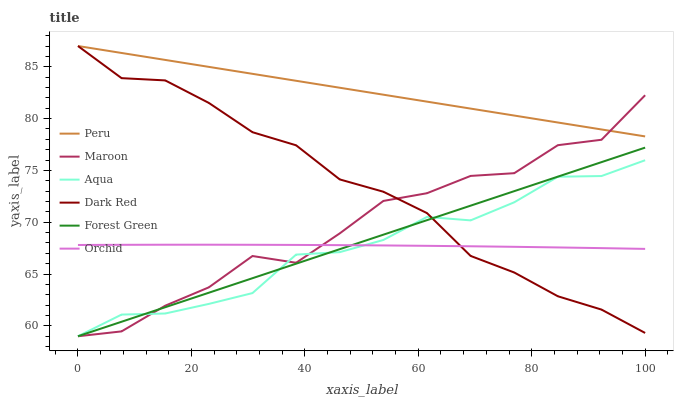Does Aqua have the minimum area under the curve?
Answer yes or no. Yes. Does Peru have the maximum area under the curve?
Answer yes or no. Yes. Does Maroon have the minimum area under the curve?
Answer yes or no. No. Does Maroon have the maximum area under the curve?
Answer yes or no. No. Is Forest Green the smoothest?
Answer yes or no. Yes. Is Maroon the roughest?
Answer yes or no. Yes. Is Aqua the smoothest?
Answer yes or no. No. Is Aqua the roughest?
Answer yes or no. No. Does Aqua have the lowest value?
Answer yes or no. Yes. Does Peru have the lowest value?
Answer yes or no. No. Does Peru have the highest value?
Answer yes or no. Yes. Does Aqua have the highest value?
Answer yes or no. No. Is Orchid less than Peru?
Answer yes or no. Yes. Is Peru greater than Orchid?
Answer yes or no. Yes. Does Peru intersect Maroon?
Answer yes or no. Yes. Is Peru less than Maroon?
Answer yes or no. No. Is Peru greater than Maroon?
Answer yes or no. No. Does Orchid intersect Peru?
Answer yes or no. No. 